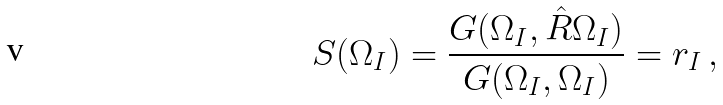Convert formula to latex. <formula><loc_0><loc_0><loc_500><loc_500>S ( \Omega _ { I } ) = \frac { G ( \Omega _ { I } , \hat { R } \Omega _ { I } ) } { G ( \Omega _ { I } , \Omega _ { I } ) } = r _ { I } \, ,</formula> 